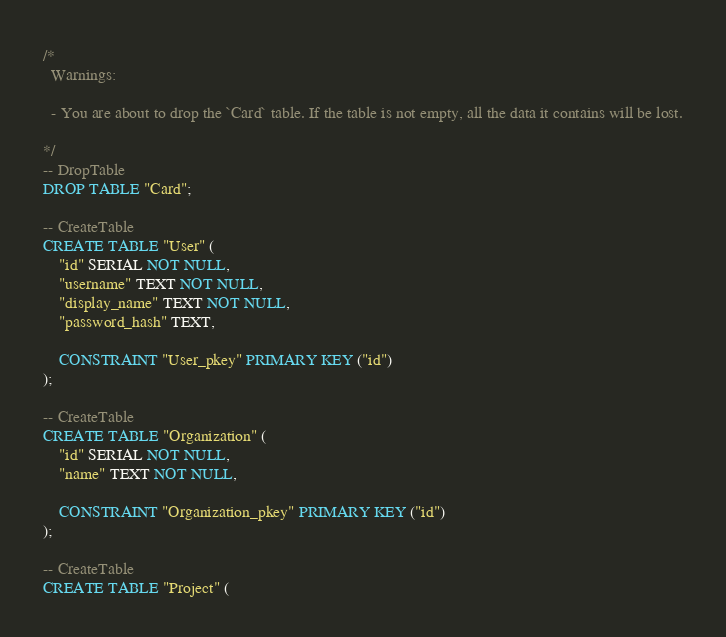<code> <loc_0><loc_0><loc_500><loc_500><_SQL_>/*
  Warnings:

  - You are about to drop the `Card` table. If the table is not empty, all the data it contains will be lost.

*/
-- DropTable
DROP TABLE "Card";

-- CreateTable
CREATE TABLE "User" (
    "id" SERIAL NOT NULL,
    "username" TEXT NOT NULL,
    "display_name" TEXT NOT NULL,
    "password_hash" TEXT,

    CONSTRAINT "User_pkey" PRIMARY KEY ("id")
);

-- CreateTable
CREATE TABLE "Organization" (
    "id" SERIAL NOT NULL,
    "name" TEXT NOT NULL,

    CONSTRAINT "Organization_pkey" PRIMARY KEY ("id")
);

-- CreateTable
CREATE TABLE "Project" (</code> 